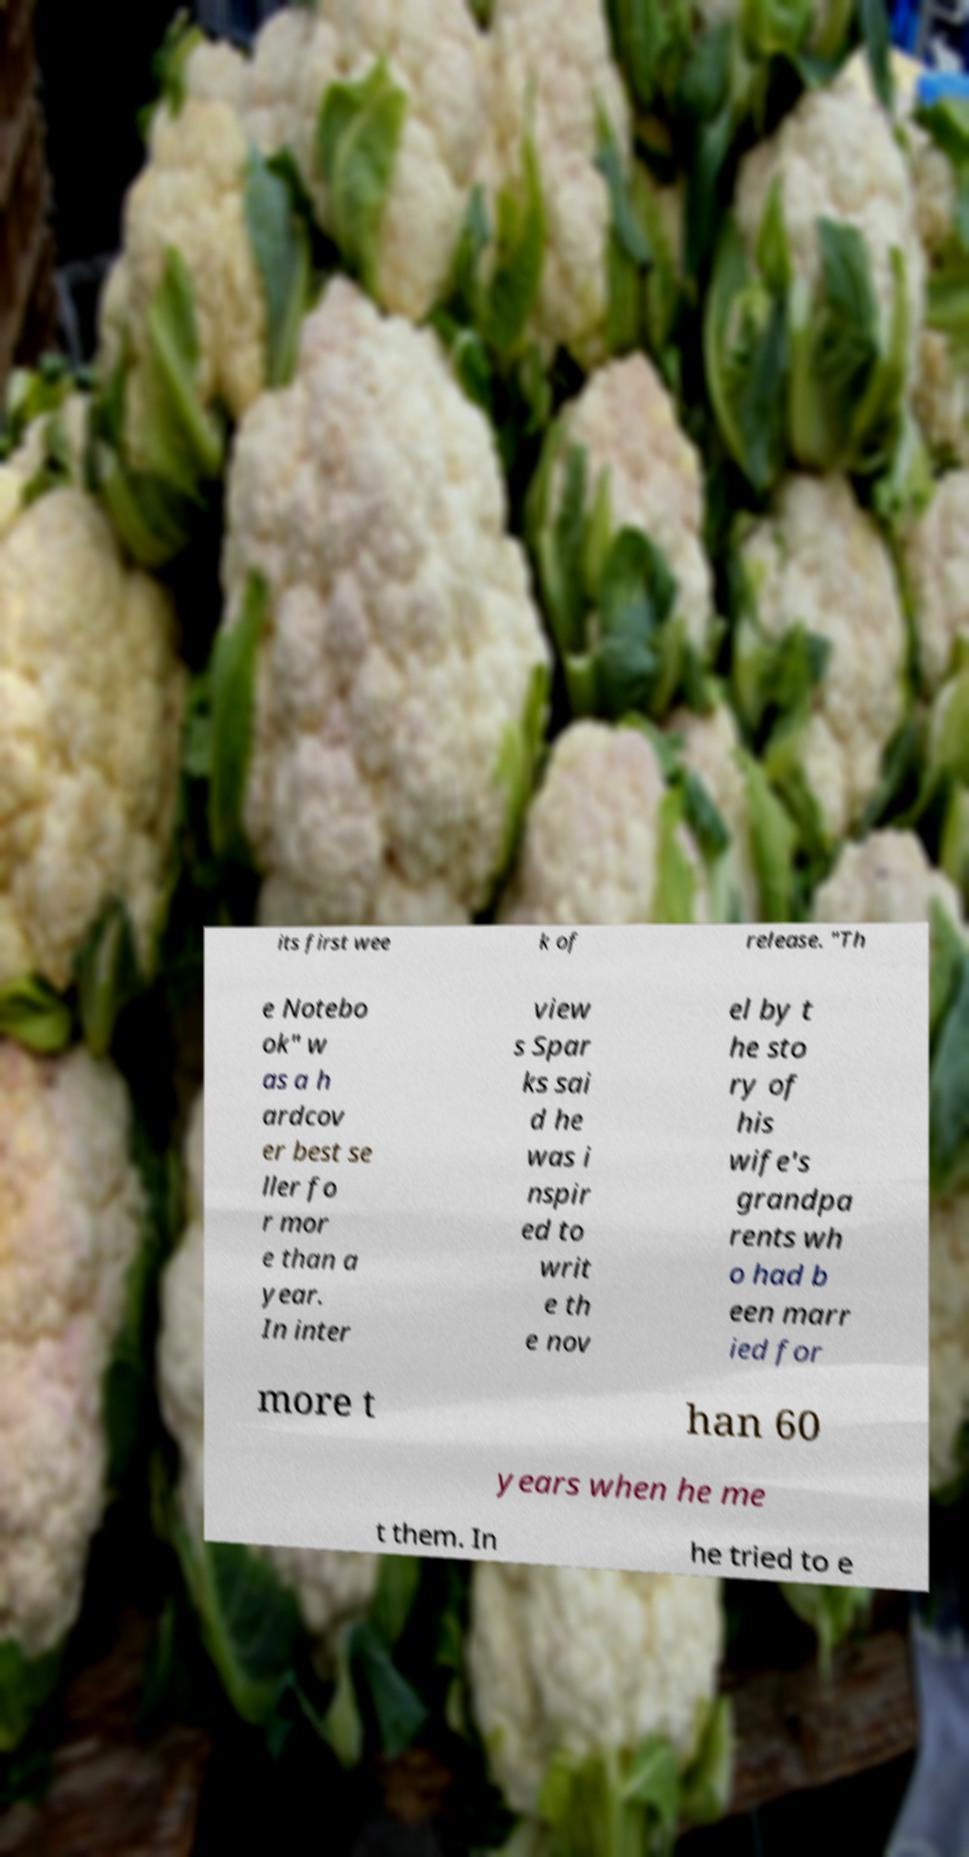Can you read and provide the text displayed in the image?This photo seems to have some interesting text. Can you extract and type it out for me? its first wee k of release. "Th e Notebo ok" w as a h ardcov er best se ller fo r mor e than a year. In inter view s Spar ks sai d he was i nspir ed to writ e th e nov el by t he sto ry of his wife's grandpa rents wh o had b een marr ied for more t han 60 years when he me t them. In he tried to e 